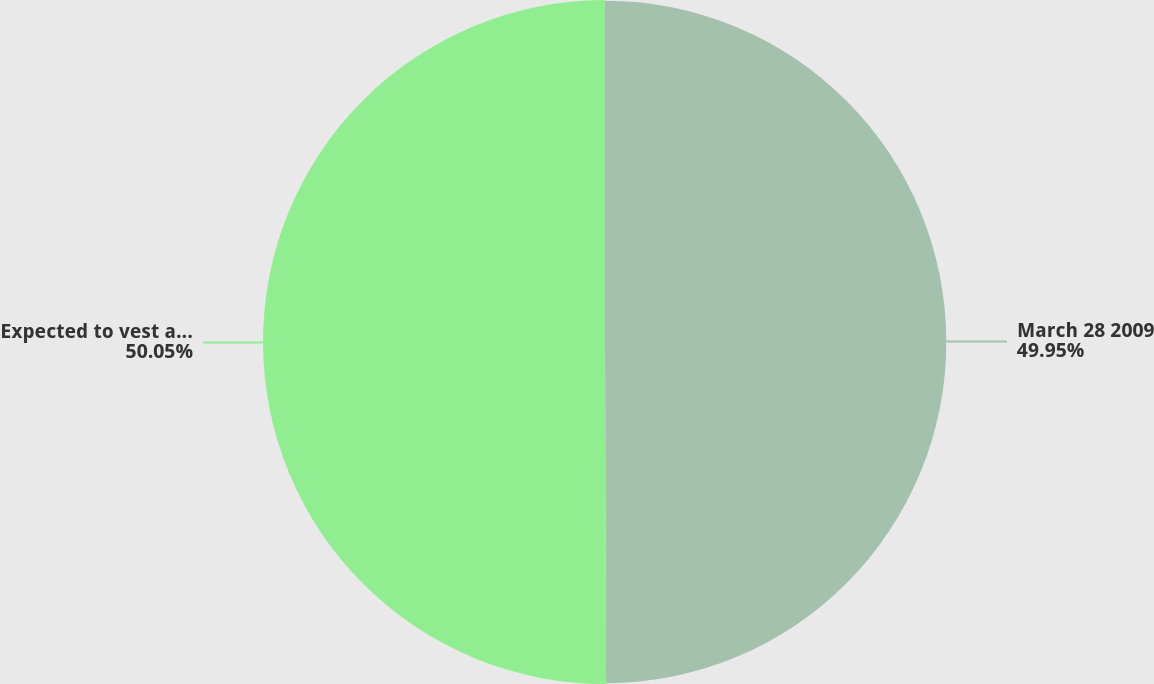Convert chart to OTSL. <chart><loc_0><loc_0><loc_500><loc_500><pie_chart><fcel>March 28 2009<fcel>Expected to vest as of March<nl><fcel>49.95%<fcel>50.05%<nl></chart> 